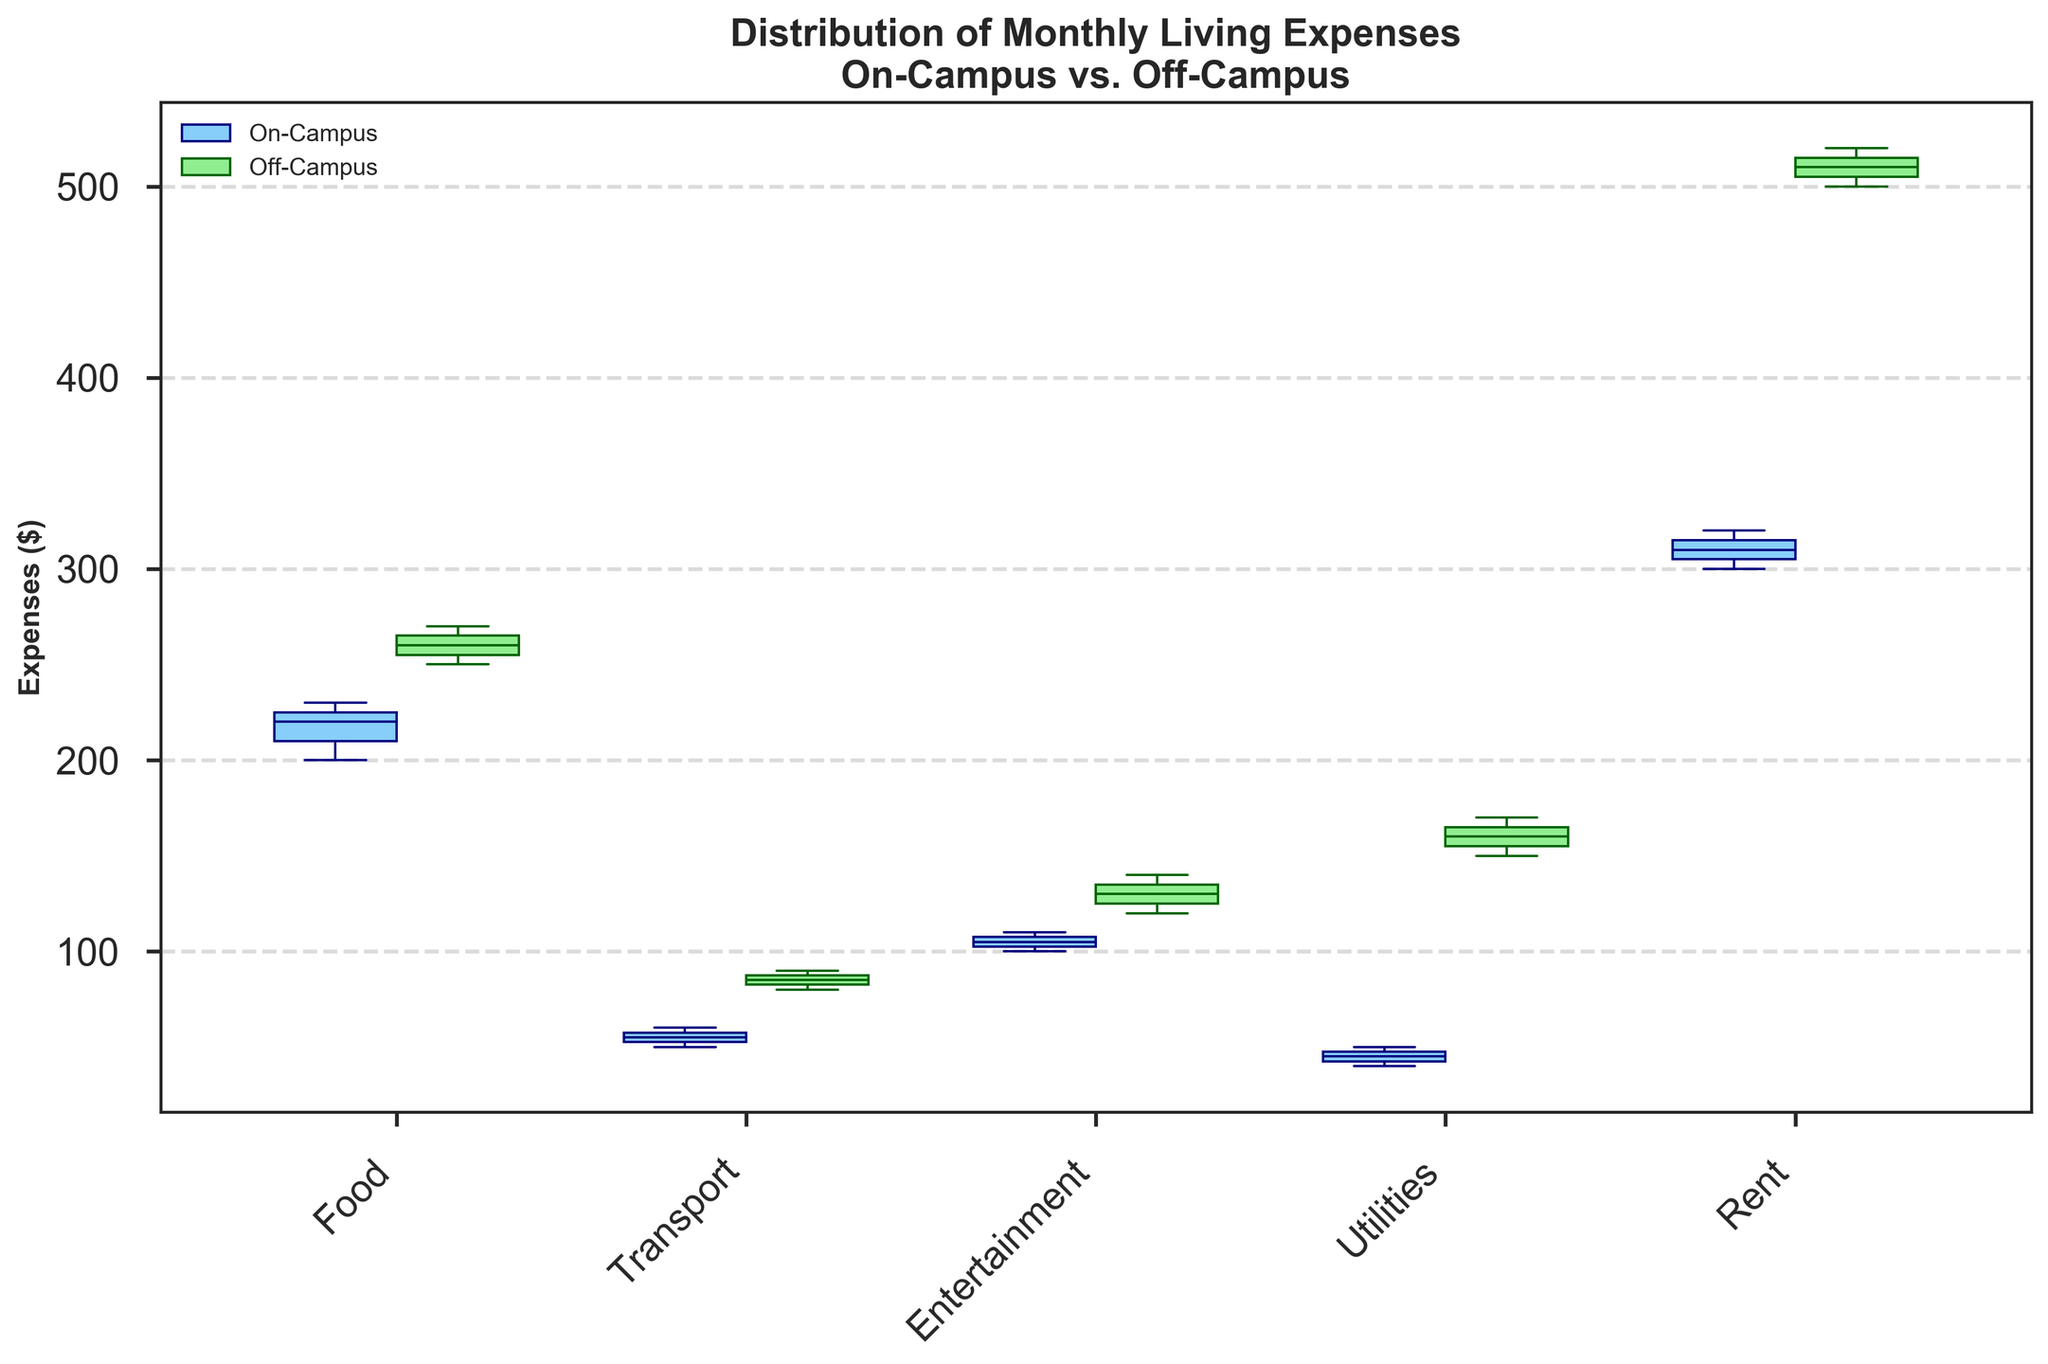What is the title of the grouped box plot? The title can be found at the top of the plot. It is written in bold and summarizes what the figure is illustrating.
Answer: Distribution of Monthly Living Expenses\nOn-Campus vs. Off-Campus What categories of living expenses are compared on the x-axis? The x-axis labels are rotated at a 45-degree angle and include all the categories of living expenses. These are Food, Transport, Entertainment, Utilities, and Rent.
Answer: Food, Transport, Entertainment, Utilities, Rent What is the median expense for On-Campus students for the Food category? Locate the median line within the on-campus box for the Food category, which is visually represented by the boxplot on the left side within each category cluster.
Answer: 220 Which living status, On-Campus or Off-Campus, has a higher median rent expense? Compare the median lines of the Rent box plots for both living statuses. The off-campus box will show a higher median line.
Answer: Off-Campus Are the utilities expenses more variable for on-campus or off-campus students? The variability of expenses can be gauged from the height of the box and length of the whiskers. The Utilities category for off-campus students has a taller box and longer whiskers, indicating higher variability.
Answer: Off-Campus Which category has the smallest difference in median expenses between On-Campus and Off-Campus students? Compare the median lines for each category. The category with the smallest distance between the medians will be the smallest difference. Observe that the Food category has the smallest difference in median expenses.
Answer: Food What is the range of the Transport expenses for Off-Campus students? The range is the difference between the top and bottom edges of the whiskers (extremes of the boxplot). For Off-Campus Transport, the bottom whisker is at approximately 85 and the top whisker is at 90.
Answer: 5 Which category shows the largest median expense for off-campus students? Check the median lines for the off-campus box in each category and identify the highest one. The Rent category for off-campus students has the highest median at 510.
Answer: Rent How do the median Entertainment expenses compare between On-Campus and Off-Campus students? Compare the positions of the median lines within the Entertainment category for both living statuses. Off-Campus has a higher median than On-Campus.
Answer: Off-Campus In which category is the difference between the first quartile (Q1) and third quartile (Q3) largest for On-Campus students? The interquartile range (IQR) is the distance between Q1 and Q3, represented by the box height. Identify the tallest box for On-Campus categories. The Rent category for On-Campus students has the largest IQR.
Answer: Rent 